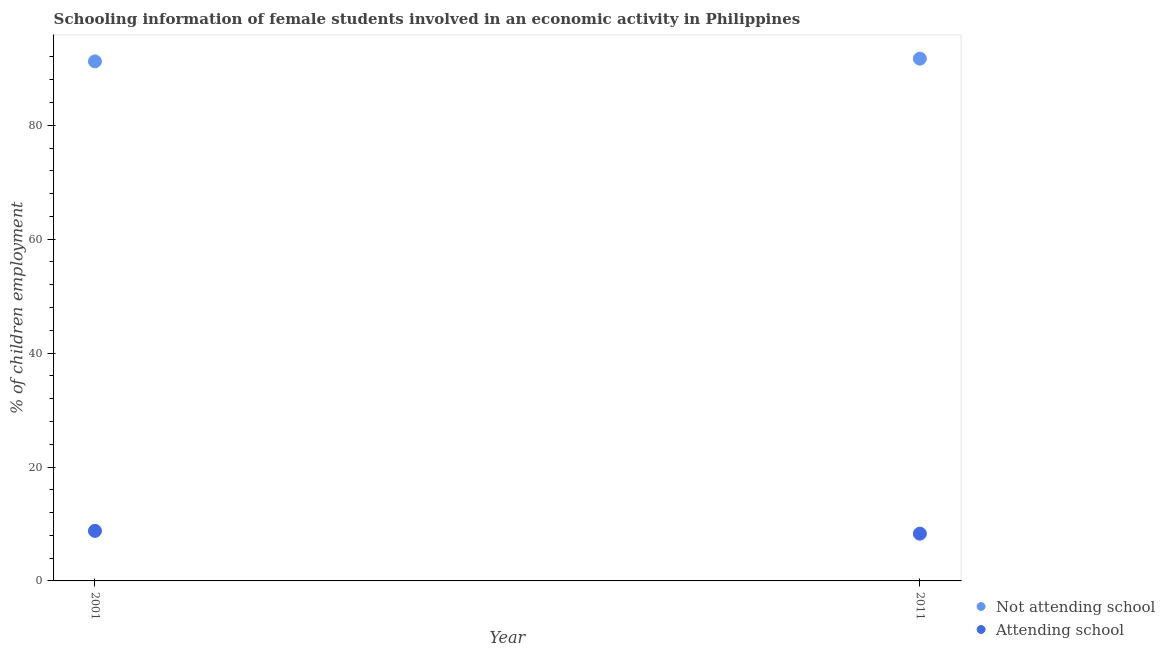How many different coloured dotlines are there?
Offer a very short reply. 2. Is the number of dotlines equal to the number of legend labels?
Your response must be concise. Yes. What is the percentage of employed females who are attending school in 2001?
Your answer should be very brief. 8.79. Across all years, what is the maximum percentage of employed females who are attending school?
Your answer should be compact. 8.79. Across all years, what is the minimum percentage of employed females who are not attending school?
Provide a short and direct response. 91.21. In which year was the percentage of employed females who are not attending school maximum?
Provide a succinct answer. 2011. In which year was the percentage of employed females who are not attending school minimum?
Your answer should be compact. 2001. What is the total percentage of employed females who are attending school in the graph?
Your answer should be compact. 17.09. What is the difference between the percentage of employed females who are not attending school in 2001 and that in 2011?
Keep it short and to the point. -0.49. What is the difference between the percentage of employed females who are not attending school in 2011 and the percentage of employed females who are attending school in 2001?
Your response must be concise. 82.91. What is the average percentage of employed females who are attending school per year?
Ensure brevity in your answer.  8.54. In the year 2011, what is the difference between the percentage of employed females who are not attending school and percentage of employed females who are attending school?
Give a very brief answer. 83.4. In how many years, is the percentage of employed females who are attending school greater than 8 %?
Offer a terse response. 2. What is the ratio of the percentage of employed females who are attending school in 2001 to that in 2011?
Provide a succinct answer. 1.06. In how many years, is the percentage of employed females who are attending school greater than the average percentage of employed females who are attending school taken over all years?
Keep it short and to the point. 1. How many dotlines are there?
Make the answer very short. 2. What is the difference between two consecutive major ticks on the Y-axis?
Provide a short and direct response. 20. Does the graph contain any zero values?
Your answer should be very brief. No. What is the title of the graph?
Your response must be concise. Schooling information of female students involved in an economic activity in Philippines. What is the label or title of the X-axis?
Your answer should be very brief. Year. What is the label or title of the Y-axis?
Give a very brief answer. % of children employment. What is the % of children employment of Not attending school in 2001?
Your answer should be very brief. 91.21. What is the % of children employment of Attending school in 2001?
Ensure brevity in your answer.  8.79. What is the % of children employment in Not attending school in 2011?
Your response must be concise. 91.7. Across all years, what is the maximum % of children employment in Not attending school?
Your answer should be very brief. 91.7. Across all years, what is the maximum % of children employment of Attending school?
Your response must be concise. 8.79. Across all years, what is the minimum % of children employment of Not attending school?
Keep it short and to the point. 91.21. Across all years, what is the minimum % of children employment in Attending school?
Give a very brief answer. 8.3. What is the total % of children employment of Not attending school in the graph?
Make the answer very short. 182.91. What is the total % of children employment in Attending school in the graph?
Offer a terse response. 17.09. What is the difference between the % of children employment in Not attending school in 2001 and that in 2011?
Provide a short and direct response. -0.49. What is the difference between the % of children employment in Attending school in 2001 and that in 2011?
Provide a short and direct response. 0.49. What is the difference between the % of children employment in Not attending school in 2001 and the % of children employment in Attending school in 2011?
Make the answer very short. 82.91. What is the average % of children employment in Not attending school per year?
Offer a terse response. 91.46. What is the average % of children employment in Attending school per year?
Give a very brief answer. 8.54. In the year 2001, what is the difference between the % of children employment in Not attending school and % of children employment in Attending school?
Ensure brevity in your answer.  82.43. In the year 2011, what is the difference between the % of children employment of Not attending school and % of children employment of Attending school?
Provide a succinct answer. 83.4. What is the ratio of the % of children employment of Attending school in 2001 to that in 2011?
Make the answer very short. 1.06. What is the difference between the highest and the second highest % of children employment in Not attending school?
Keep it short and to the point. 0.49. What is the difference between the highest and the second highest % of children employment of Attending school?
Make the answer very short. 0.49. What is the difference between the highest and the lowest % of children employment of Not attending school?
Make the answer very short. 0.49. What is the difference between the highest and the lowest % of children employment of Attending school?
Make the answer very short. 0.49. 